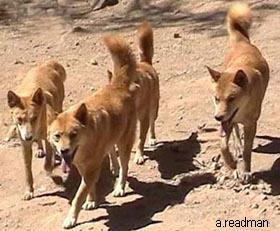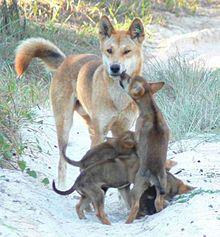The first image is the image on the left, the second image is the image on the right. For the images displayed, is the sentence "There appear to be exactly eight dogs." factually correct? Answer yes or no. Yes. The first image is the image on the left, the second image is the image on the right. Analyze the images presented: Is the assertion "There ais at least one dog standing on a rocky hill" valid? Answer yes or no. No. 